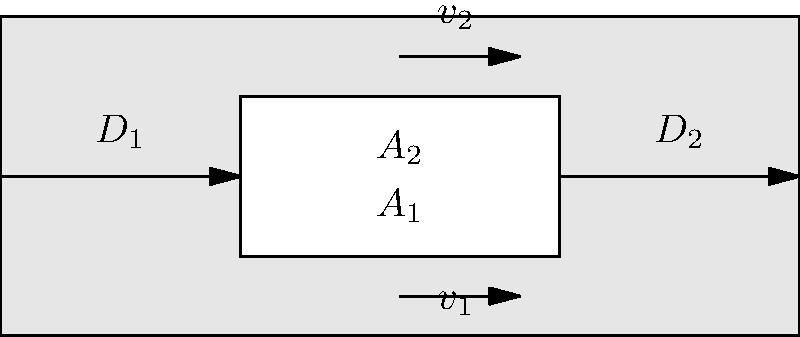In the pipe shown above, water flows from left to right. The diameter of the pipe changes from $D_1$ to $D_2$, where $D_2 < D_1$. If the velocity of water in the wider section is $v_1 = 2$ m/s, what is the velocity $v_2$ in the narrower section if $D_1 = 3D_2$? To solve this problem, we'll use the principle of continuity in fluid dynamics. Here's a step-by-step explanation:

1) The continuity equation states that the mass flow rate is constant throughout the pipe. This can be expressed as:

   $$ A_1v_1 = A_2v_2 $$

   where $A_1$ and $A_2$ are the cross-sectional areas of the wider and narrower sections, respectively.

2) The cross-sectional area of a circular pipe is proportional to the square of its diameter. We're told that $D_1 = 3D_2$, so:

   $$ A_1 = \frac{\pi D_1^2}{4} = \frac{\pi (3D_2)^2}{4} = 9 \frac{\pi D_2^2}{4} = 9A_2 $$

3) Substituting this into our continuity equation:

   $$ 9A_2 v_1 = A_2 v_2 $$

4) We can now cancel out $A_2$ from both sides:

   $$ 9v_1 = v_2 $$

5) We're given that $v_1 = 2$ m/s, so:

   $$ v_2 = 9 \times 2 \text{ m/s} = 18 \text{ m/s} $$

Therefore, the velocity in the narrower section is 18 m/s.
Answer: 18 m/s 